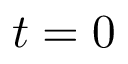<formula> <loc_0><loc_0><loc_500><loc_500>t = 0</formula> 